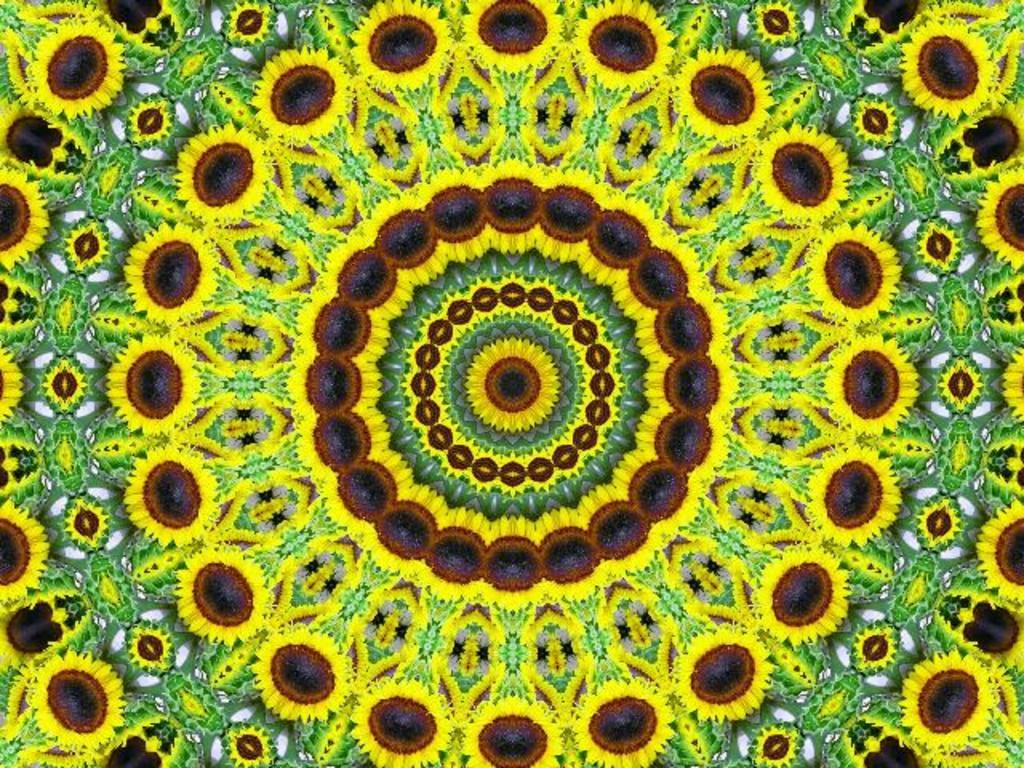What colors are used in the design of the image? The design in the image uses yellow, green, brown, and black colors. What is the subject of the design? The design depicts sunflowers. What type of oil is used to create the design in the image? There is no mention of oil being used in the creation of the design in the image. The image only depicts sunflowers using the colors yellow, green, brown, and black. 